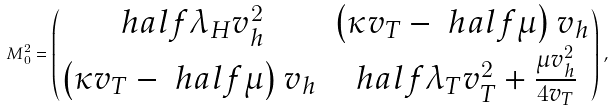<formula> <loc_0><loc_0><loc_500><loc_500>M _ { 0 } ^ { 2 } = \begin{pmatrix} \ h a l f \lambda _ { H } v _ { h } ^ { 2 } & \left ( \kappa v _ { T } - \ h a l f \mu \right ) v _ { h } \\ \left ( \kappa v _ { T } - \ h a l f \mu \right ) v _ { h } & \ h a l f \lambda _ { T } v _ { T } ^ { 2 } + \frac { \mu v _ { h } ^ { 2 } } { 4 v _ { T } } \end{pmatrix} \, ,</formula> 